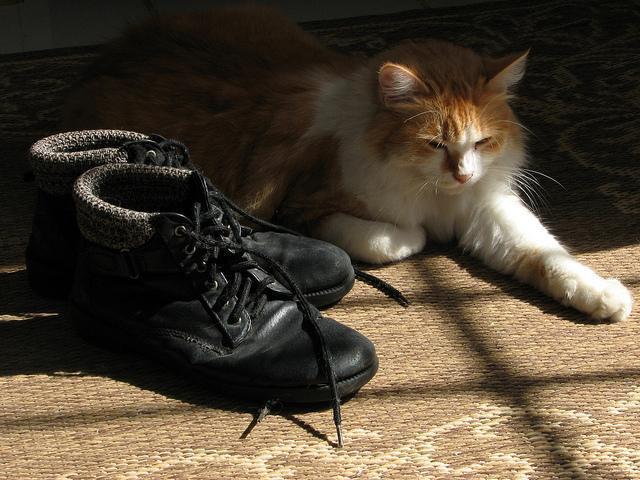How many slices of pizza are there?
Give a very brief answer. 0. 